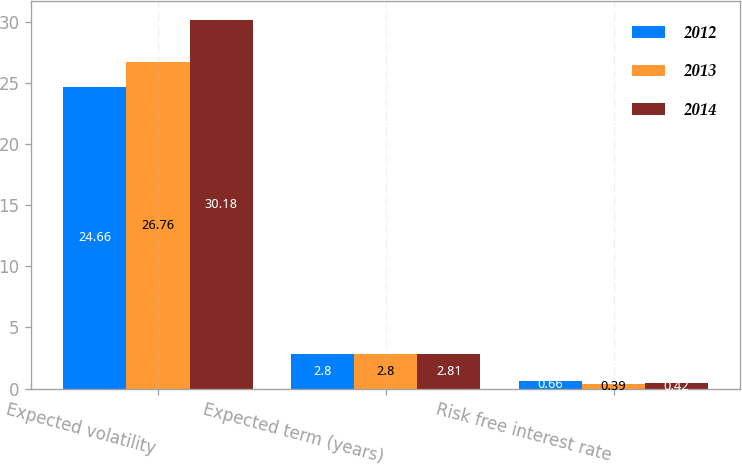<chart> <loc_0><loc_0><loc_500><loc_500><stacked_bar_chart><ecel><fcel>Expected volatility<fcel>Expected term (years)<fcel>Risk free interest rate<nl><fcel>2012<fcel>24.66<fcel>2.8<fcel>0.66<nl><fcel>2013<fcel>26.76<fcel>2.8<fcel>0.39<nl><fcel>2014<fcel>30.18<fcel>2.81<fcel>0.42<nl></chart> 